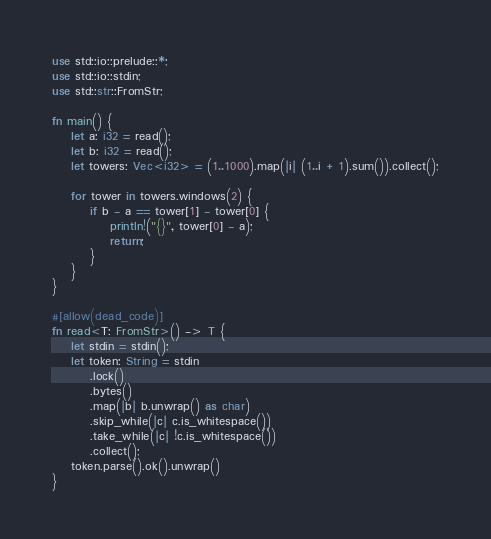<code> <loc_0><loc_0><loc_500><loc_500><_Rust_>use std::io::prelude::*;
use std::io::stdin;
use std::str::FromStr;

fn main() {
    let a: i32 = read();
    let b: i32 = read();
    let towers: Vec<i32> = (1..1000).map(|i| (1..i + 1).sum()).collect();

    for tower in towers.windows(2) {
        if b - a == tower[1] - tower[0] {
            println!("{}", tower[0] - a);
            return;
        }
    }
}

#[allow(dead_code)]
fn read<T: FromStr>() -> T {
    let stdin = stdin();
    let token: String = stdin
        .lock()
        .bytes()
        .map(|b| b.unwrap() as char)
        .skip_while(|c| c.is_whitespace())
        .take_while(|c| !c.is_whitespace())
        .collect();
    token.parse().ok().unwrap()
}
</code> 